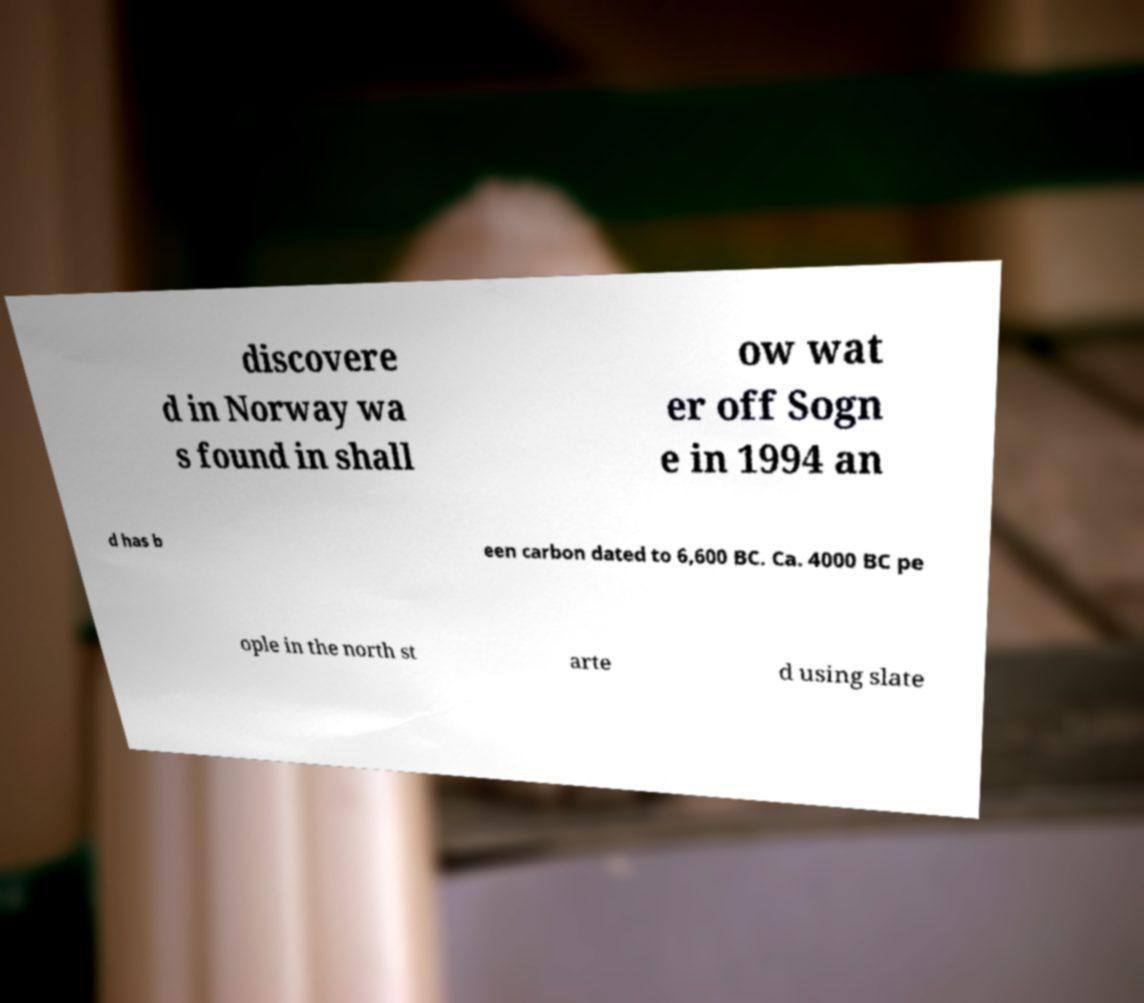Could you assist in decoding the text presented in this image and type it out clearly? discovere d in Norway wa s found in shall ow wat er off Sogn e in 1994 an d has b een carbon dated to 6,600 BC. Ca. 4000 BC pe ople in the north st arte d using slate 